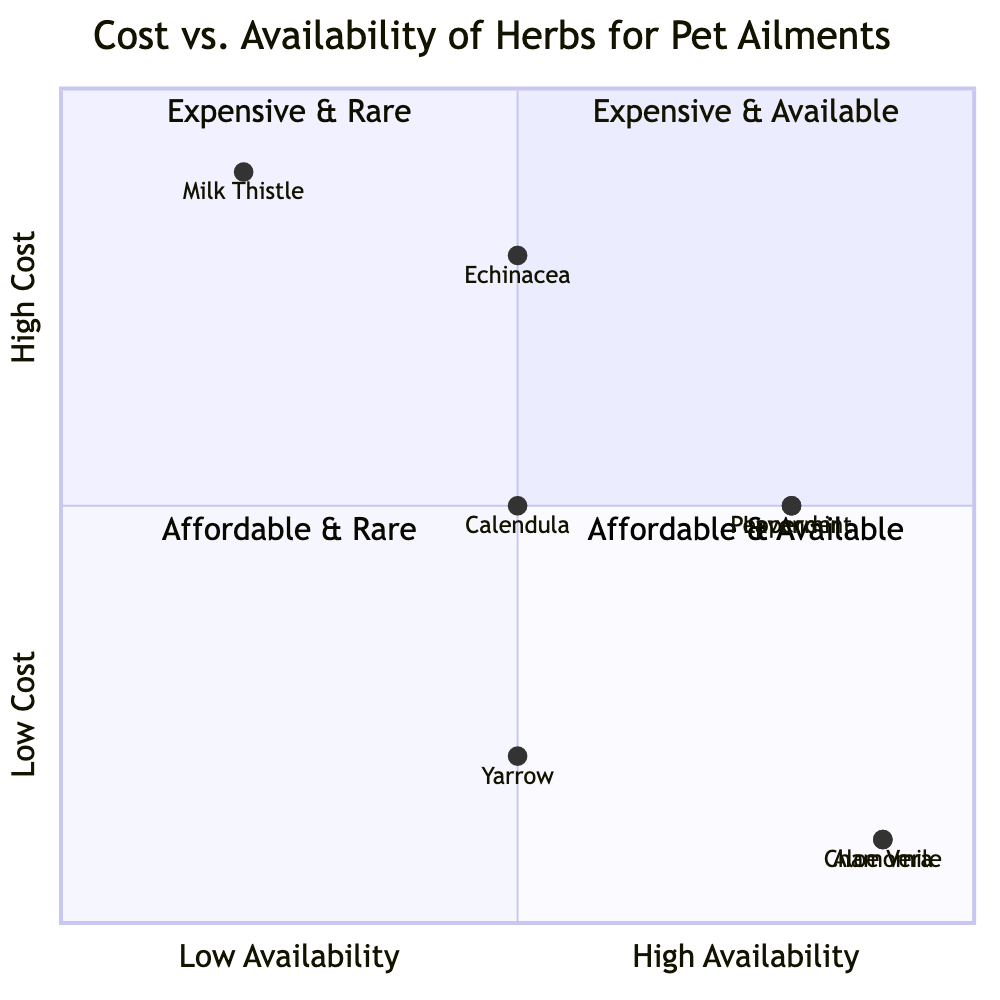What is the availability level of Chamomile? Chamomile is located in the quadrant where cost is low and availability is high. Based on the data provided, it shows a high availability level.
Answer: high Which herb is both expensive and available? In the quadrant chart, the expensive and available category is empty, meaning there are no herbs that fit this description.
Answer: none How many herbs are classified as low cost? By looking at the chart, we can identify the herbs in the low-cost quadrant and count them. There are four herbs with low cost: Chamomile, Aloe Vera, Yarrow, and Peppermint, which places them in the appropriate quadrants.
Answer: four What is the availability of Milk Thistle? Milk Thistle's position is in the quadrant designated for high cost and low availability. Therefore, it has a low availability level.
Answer: low Which is the most expensive herb in the chart? By analyzing the cost mapping of the herbs in the diagram, Milk Thistle and Echinacea are the herbs with a high cost, but Milk Thistle has the highest representation in cost based on its placement in the chart.
Answer: Milk Thistle Is Peppermint available but expensive? Peppermint is located in the quadrant for medium cost and high availability, indicating that it is indeed available but not classified as expensive.
Answer: no What color quadrant corresponds to affordable and rare herbs? Referring to the quadrants, "Affordable & Rare" is quadrant three which is colored in a specific way that distinguishes it from the other quadrants.
Answer: quadrant three How many total herbs have high availability? Reviewing the entire diagram reveals that there are four herbs with high availability: Chamomile, Aloe Vera, Lavender, and Peppermint.
Answer: four Which herb is both affordable and available? Within the chart, Chamomile and Aloe Vera both fall into the affordable and available categories, highlighting their status among other herbs.
Answer: Chamomile, Aloe Vera 